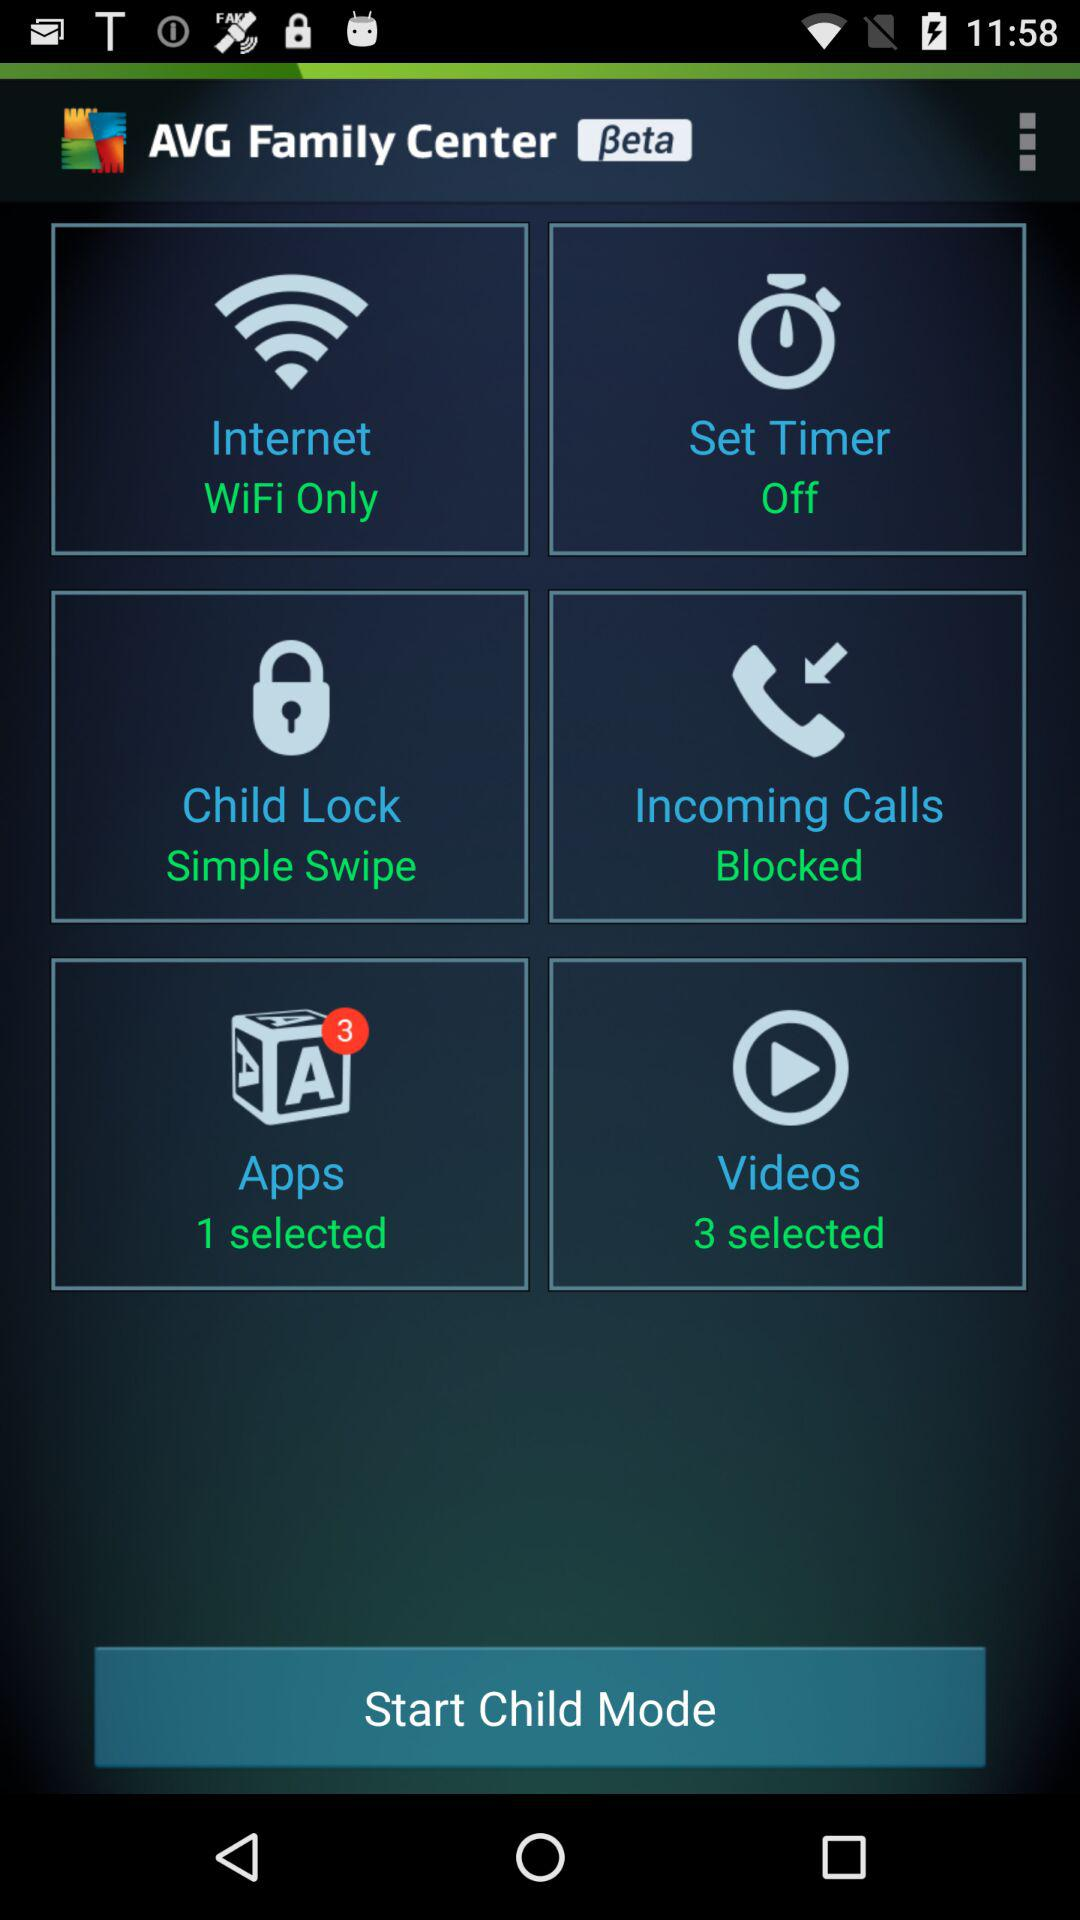How many more videos are selected than apps?
Answer the question using a single word or phrase. 2 